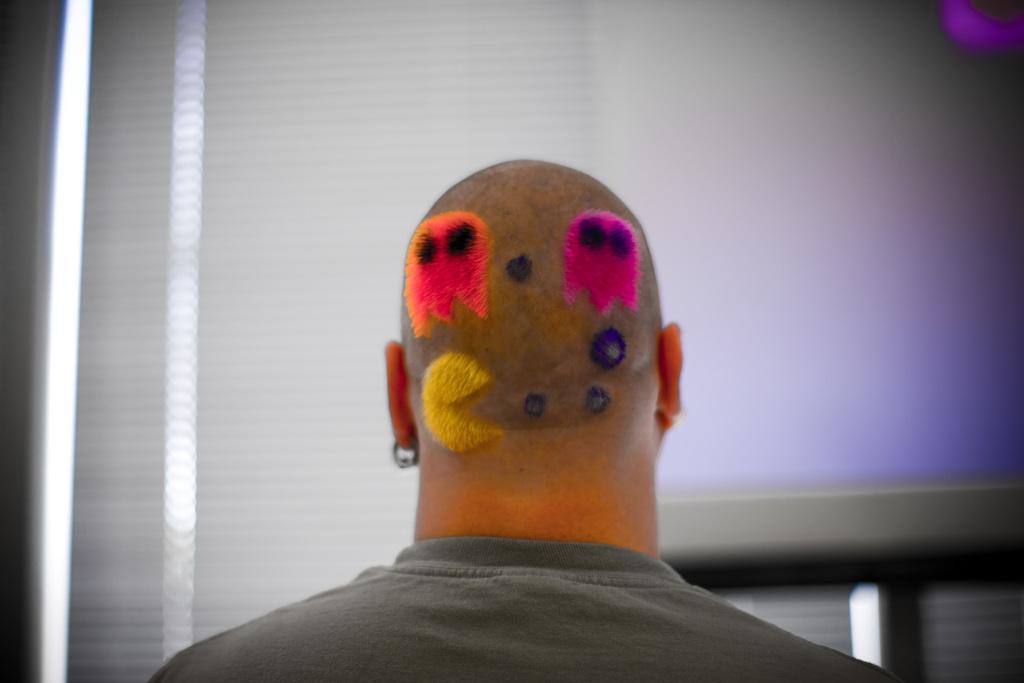Can you describe this image briefly? In this picture one man has PAC-Man hair style on his his back. 